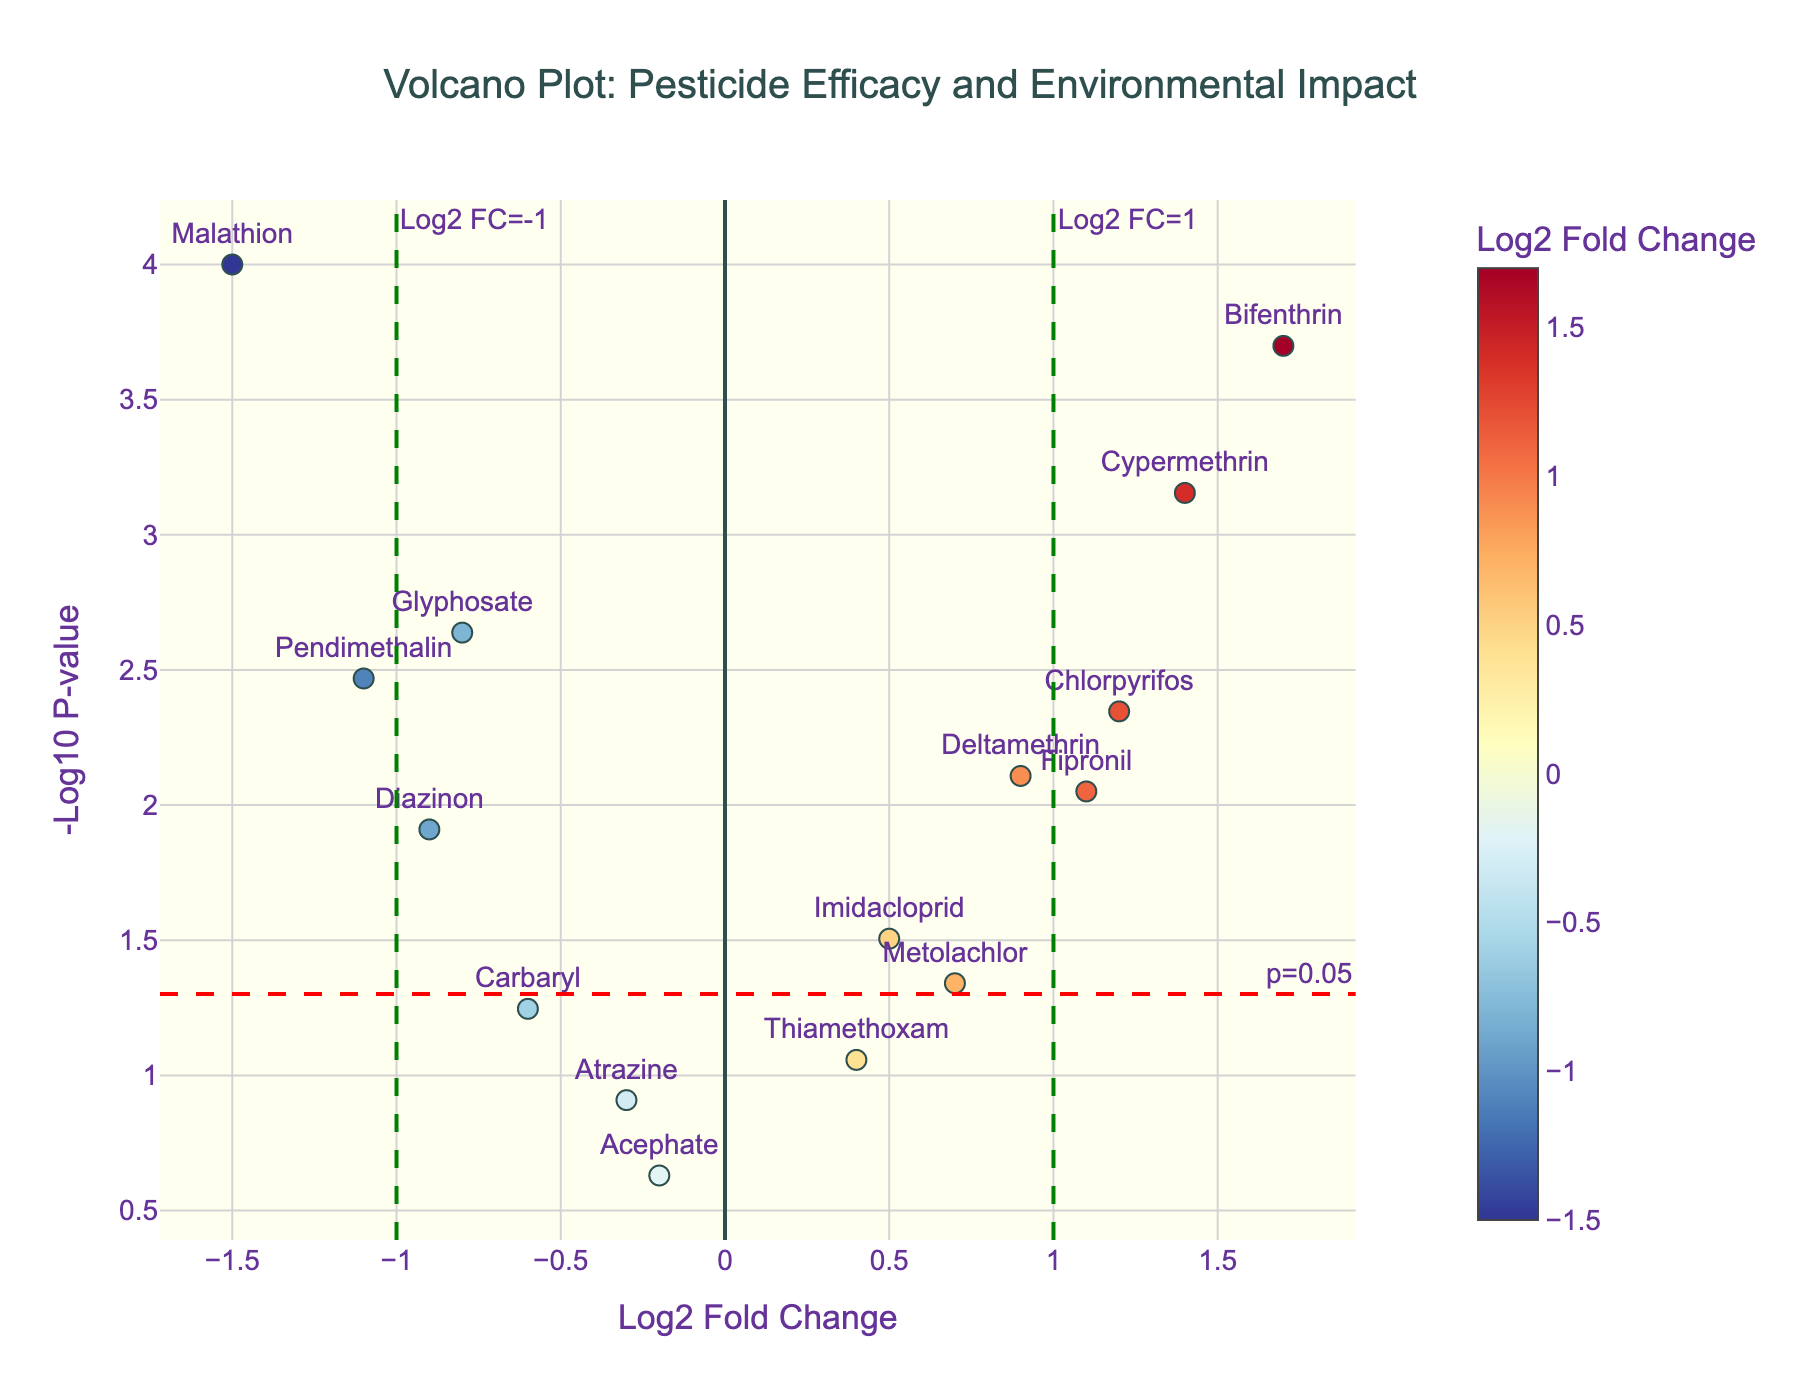What's the title of the figure? The title of the figure is found at the top and clearly states the purpose of the plot.
Answer: Volcano Plot: Pesticide Efficacy and Environmental Impact How many pesticides are represented in the plot? Each point on the plot represents a different pesticide, and counting them yields the total number. There are 15 pesticides listed in the data.
Answer: 15 Which pesticide has the highest log2 fold change? Looking for the point furthest to the right on the x-axis will show the pesticide with the highest log2 fold change. The highest log2 fold change is 1.7 for Bifenthrin.
Answer: Bifenthrin Which pesticide has the lowest p-value? The lowest p-value will correspond to the highest point on the y-axis. Malathion is the highest point, indicating it has the lowest p-value.
Answer: Malathion How many pesticides have a log2 fold change greater than 1? Points with a log2 fold change greater than 1 are to the right of the green line at x=1. Counting these points gives the number of pesticides.
Answer: 3 (Chlorpyrifos, Bifenthrin, Cypermethrin) Which pesticides fall below the p=0.05 threshold? Points below the red line represent pesticides with a p-value below 0.05. These pesticides can be identified by checking which points are above the horizontal threshold line.
Answer: Glyphosate, Chlorpyrifos, Malathion, Deltamethrin, Bifenthrin, Fipronil, Pendimethalin, Diazinon, Cypermethrin, Metolachlor Which pesticide has a log2 fold change closest to zero but still shows significant impact (p-value < 0.05)? Log2 fold change closest to zero can be found around the center of the x-axis (x=0). Among these, the one with the highest y-value will have p-value < 0.05. Glyphosate has the closest value to zero and a significant impact.
Answer: Glyphosate Among the pesticides with negative log2 fold changes, which one is the most significant (smallest p-value)? Negative log2 fold changes are to the left side of the x-axis. The one with the highest y-value among these points is the most significant. Malathion is the furthest left with the highest y-value.
Answer: Malathion What can you conclude about pesticides with p-values above 0.05 (below the red line)? Pesticides with p-values above 0.05 will be below or on the red line and generally indicate a lack of significant impact. These are Atrazine, Carbaryl, and Acephate.
Answer: They are not statistically significant 